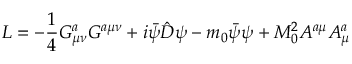Convert formula to latex. <formula><loc_0><loc_0><loc_500><loc_500>L = - \frac { 1 } { 4 } G _ { \mu \nu } ^ { a } G ^ { a \mu \nu } + i \bar { \psi } \hat { D } \psi - m _ { 0 } \bar { \psi } \psi + M _ { 0 } ^ { 2 } A ^ { a \mu } A _ { \mu } ^ { a }</formula> 